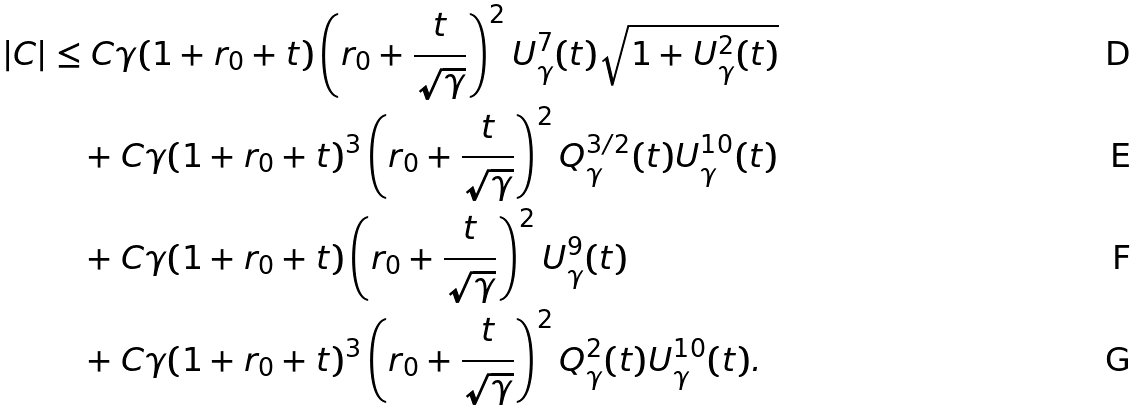<formula> <loc_0><loc_0><loc_500><loc_500>| C | & \leq C \gamma ( 1 + r _ { 0 } + t ) \left ( r _ { 0 } + \frac { t } { \sqrt { \gamma } } \right ) ^ { 2 } U _ { \gamma } ^ { 7 } ( t ) \sqrt { 1 + U _ { \gamma } ^ { 2 } ( t ) } \\ & \quad + C \gamma ( 1 + r _ { 0 } + t ) ^ { 3 } \left ( r _ { 0 } + \frac { t } { \sqrt { \gamma } } \right ) ^ { 2 } Q _ { \gamma } ^ { 3 / 2 } ( t ) U _ { \gamma } ^ { 1 0 } ( t ) \\ & \quad + C \gamma ( 1 + r _ { 0 } + t ) \left ( r _ { 0 } + \frac { t } { \sqrt { \gamma } } \right ) ^ { 2 } U _ { \gamma } ^ { 9 } ( t ) \\ & \quad + C \gamma ( 1 + r _ { 0 } + t ) ^ { 3 } \left ( r _ { 0 } + \frac { t } { \sqrt { \gamma } } \right ) ^ { 2 } Q _ { \gamma } ^ { 2 } ( t ) U _ { \gamma } ^ { 1 0 } ( t ) .</formula> 